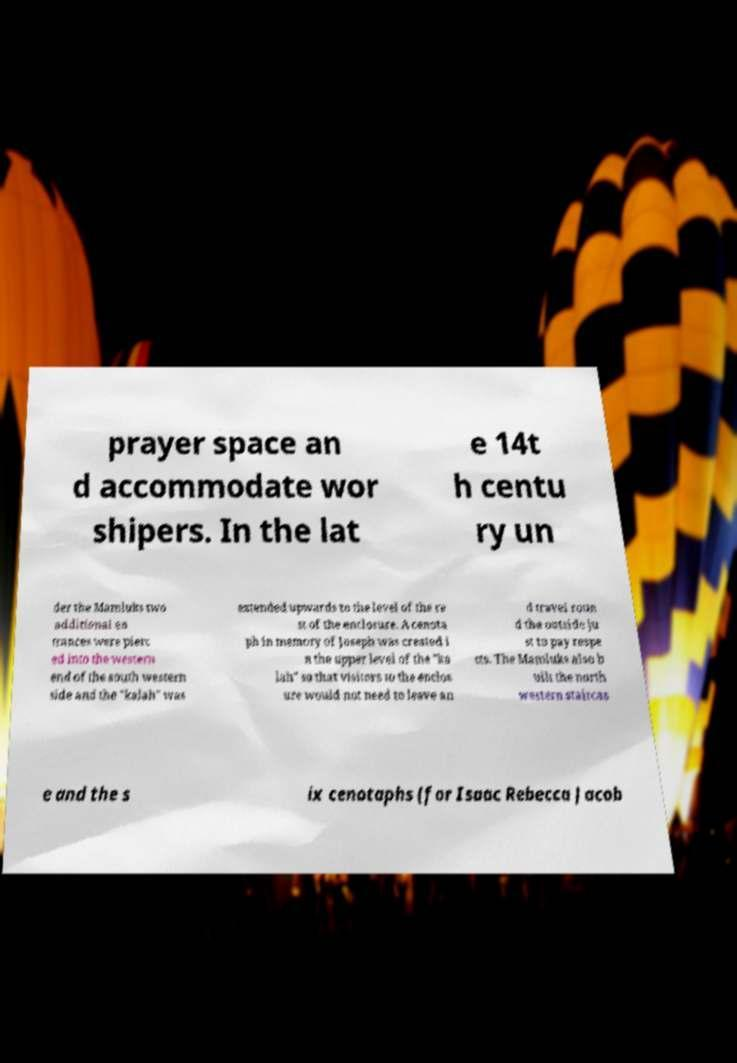I need the written content from this picture converted into text. Can you do that? prayer space an d accommodate wor shipers. In the lat e 14t h centu ry un der the Mamluks two additional en trances were pierc ed into the western end of the south western side and the "kalah" was extended upwards to the level of the re st of the enclosure. A cenota ph in memory of Joseph was created i n the upper level of the "ka lah" so that visitors to the enclos ure would not need to leave an d travel roun d the outside ju st to pay respe cts. The Mamluks also b uilt the north western staircas e and the s ix cenotaphs (for Isaac Rebecca Jacob 